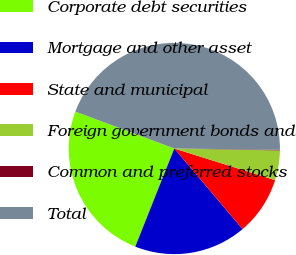Convert chart. <chart><loc_0><loc_0><loc_500><loc_500><pie_chart><fcel>Corporate debt securities<fcel>Mortgage and other asset<fcel>State and municipal<fcel>Foreign government bonds and<fcel>Common and preferred stocks<fcel>Total<nl><fcel>24.66%<fcel>17.21%<fcel>8.98%<fcel>4.54%<fcel>0.1%<fcel>44.52%<nl></chart> 